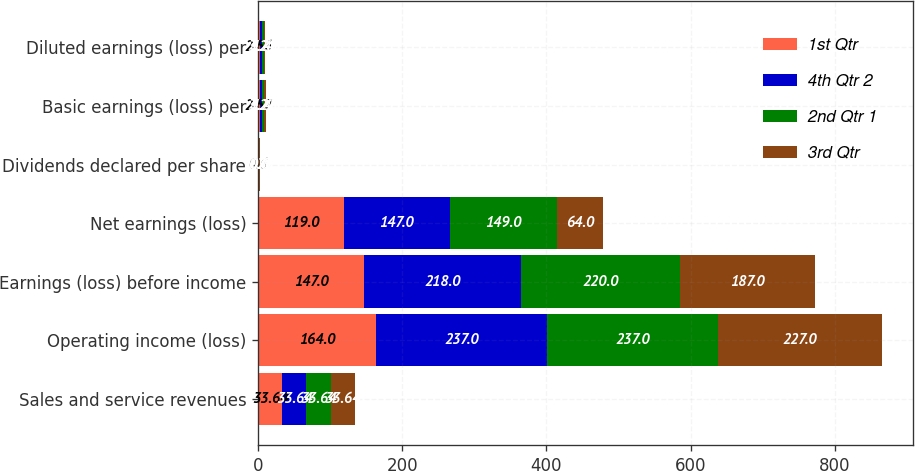Convert chart to OTSL. <chart><loc_0><loc_0><loc_500><loc_500><stacked_bar_chart><ecel><fcel>Sales and service revenues<fcel>Operating income (loss)<fcel>Earnings (loss) before income<fcel>Net earnings (loss)<fcel>Dividends declared per share<fcel>Basic earnings (loss) per<fcel>Diluted earnings (loss) per<nl><fcel>1st Qtr<fcel>33.64<fcel>164<fcel>147<fcel>119<fcel>0.6<fcel>2.57<fcel>2.56<nl><fcel>4th Qtr 2<fcel>33.64<fcel>237<fcel>218<fcel>147<fcel>0.6<fcel>3.22<fcel>3.21<nl><fcel>2nd Qtr 1<fcel>33.64<fcel>237<fcel>220<fcel>149<fcel>0.6<fcel>3.28<fcel>3.27<nl><fcel>3rd Qtr<fcel>33.64<fcel>227<fcel>187<fcel>64<fcel>0.72<fcel>1.41<fcel>1.41<nl></chart> 